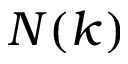<formula> <loc_0><loc_0><loc_500><loc_500>N ( k )</formula> 